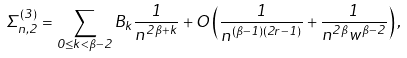<formula> <loc_0><loc_0><loc_500><loc_500>\Sigma _ { n , 2 } ^ { \left ( 3 \right ) } = \sum _ { 0 \leq k < \beta - 2 } B _ { k } \frac { 1 } { n ^ { 2 \beta + k } } + O \left ( \frac { 1 } { n ^ { ( \beta - 1 ) ( 2 r - 1 ) } } + \frac { 1 } { n ^ { 2 \beta } w ^ { \beta - 2 } } \right ) ,</formula> 